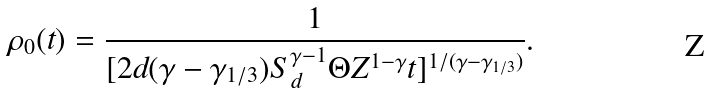<formula> <loc_0><loc_0><loc_500><loc_500>\rho _ { 0 } ( t ) = \frac { 1 } { [ 2 d ( \gamma - \gamma _ { 1 / 3 } ) S _ { d } ^ { \gamma - 1 } \Theta Z ^ { 1 - \gamma } t ] ^ { 1 / ( \gamma - \gamma _ { 1 / 3 } ) } } .</formula> 